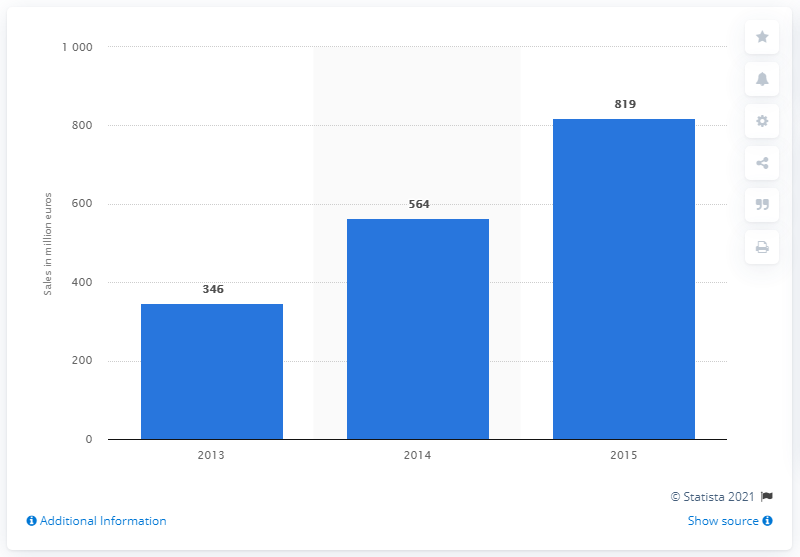Draw attention to some important aspects in this diagram. In 2014, the total sales of air cleaners worldwide were 564. 